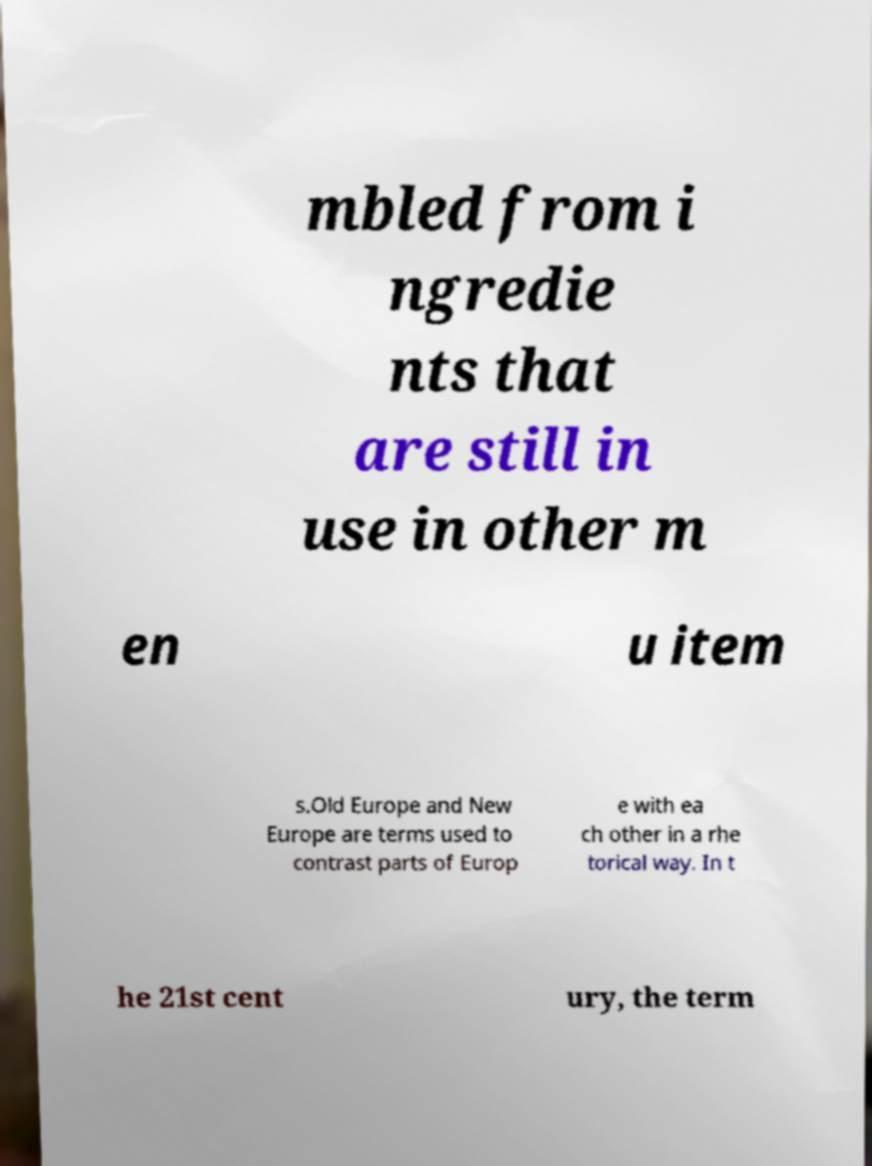Please identify and transcribe the text found in this image. mbled from i ngredie nts that are still in use in other m en u item s.Old Europe and New Europe are terms used to contrast parts of Europ e with ea ch other in a rhe torical way. In t he 21st cent ury, the term 